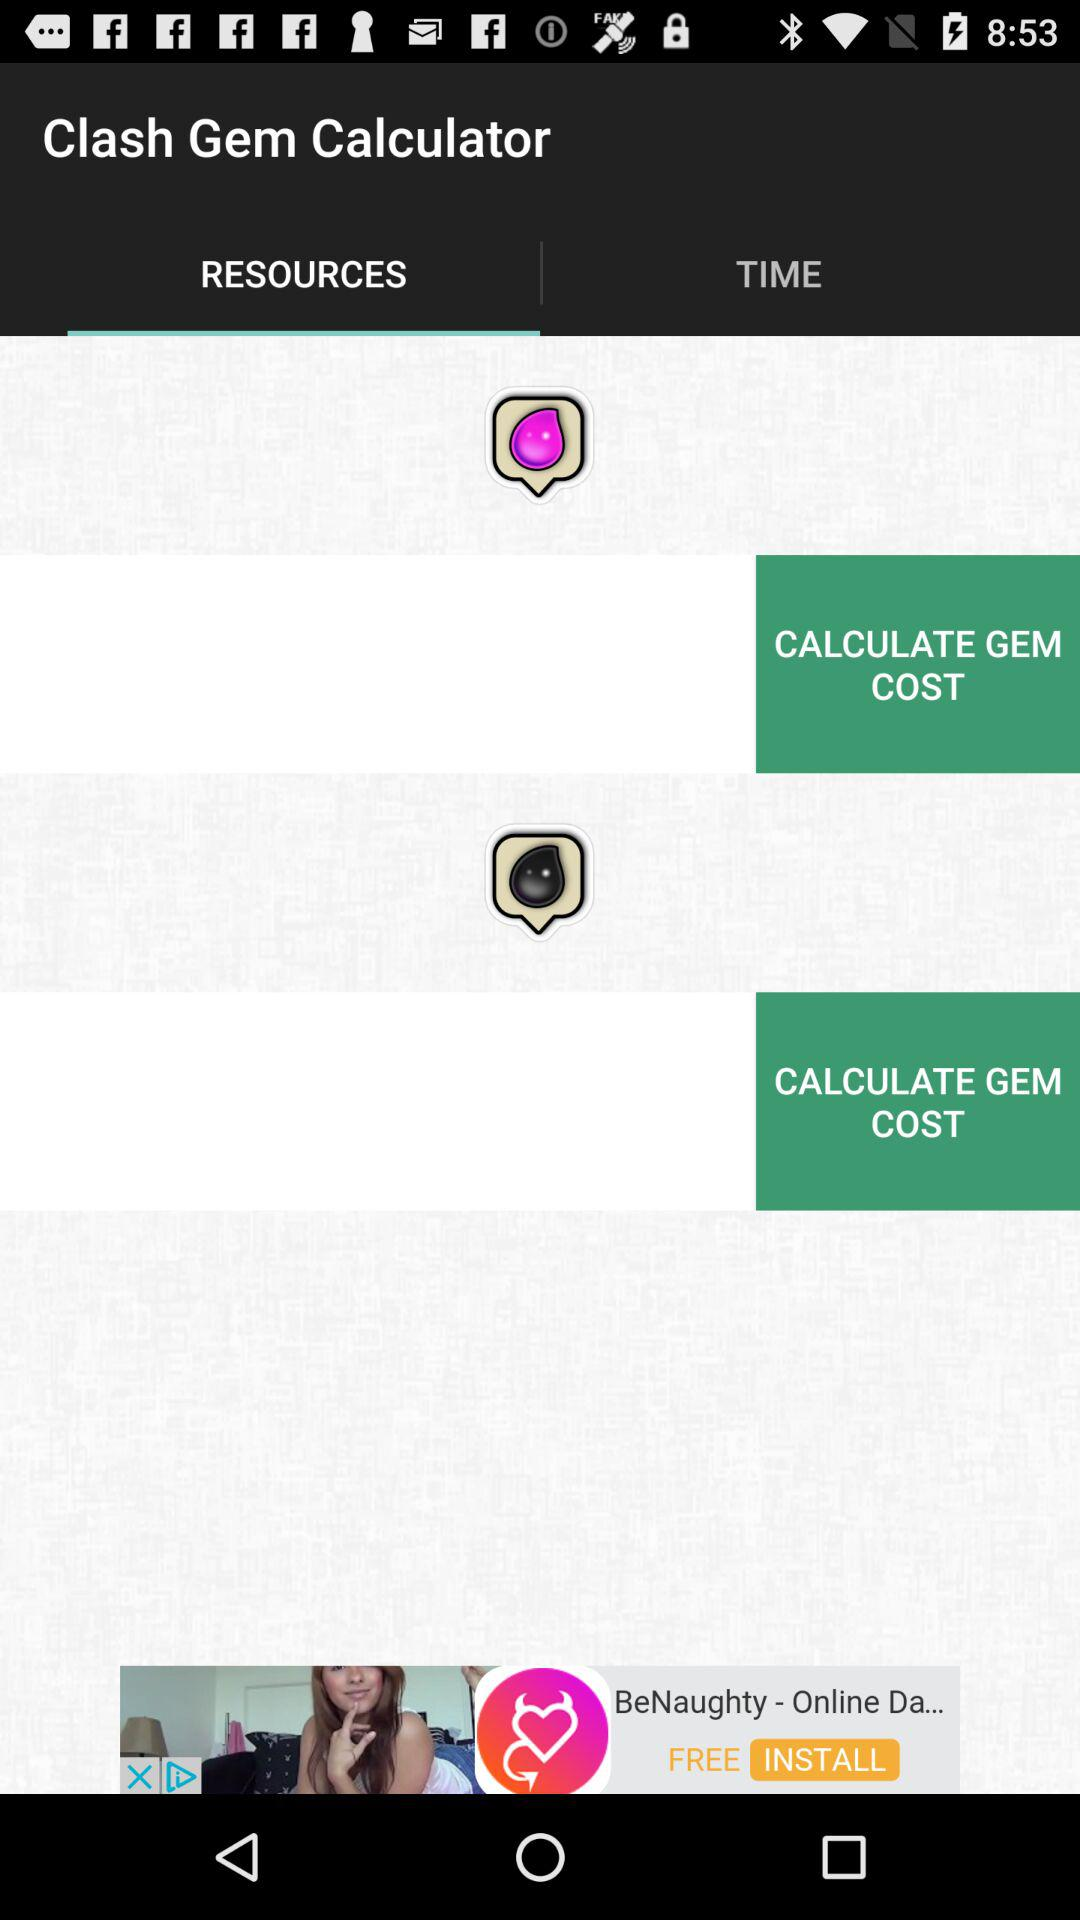What is the application name? The application name is "Clash Gem Calculator". 